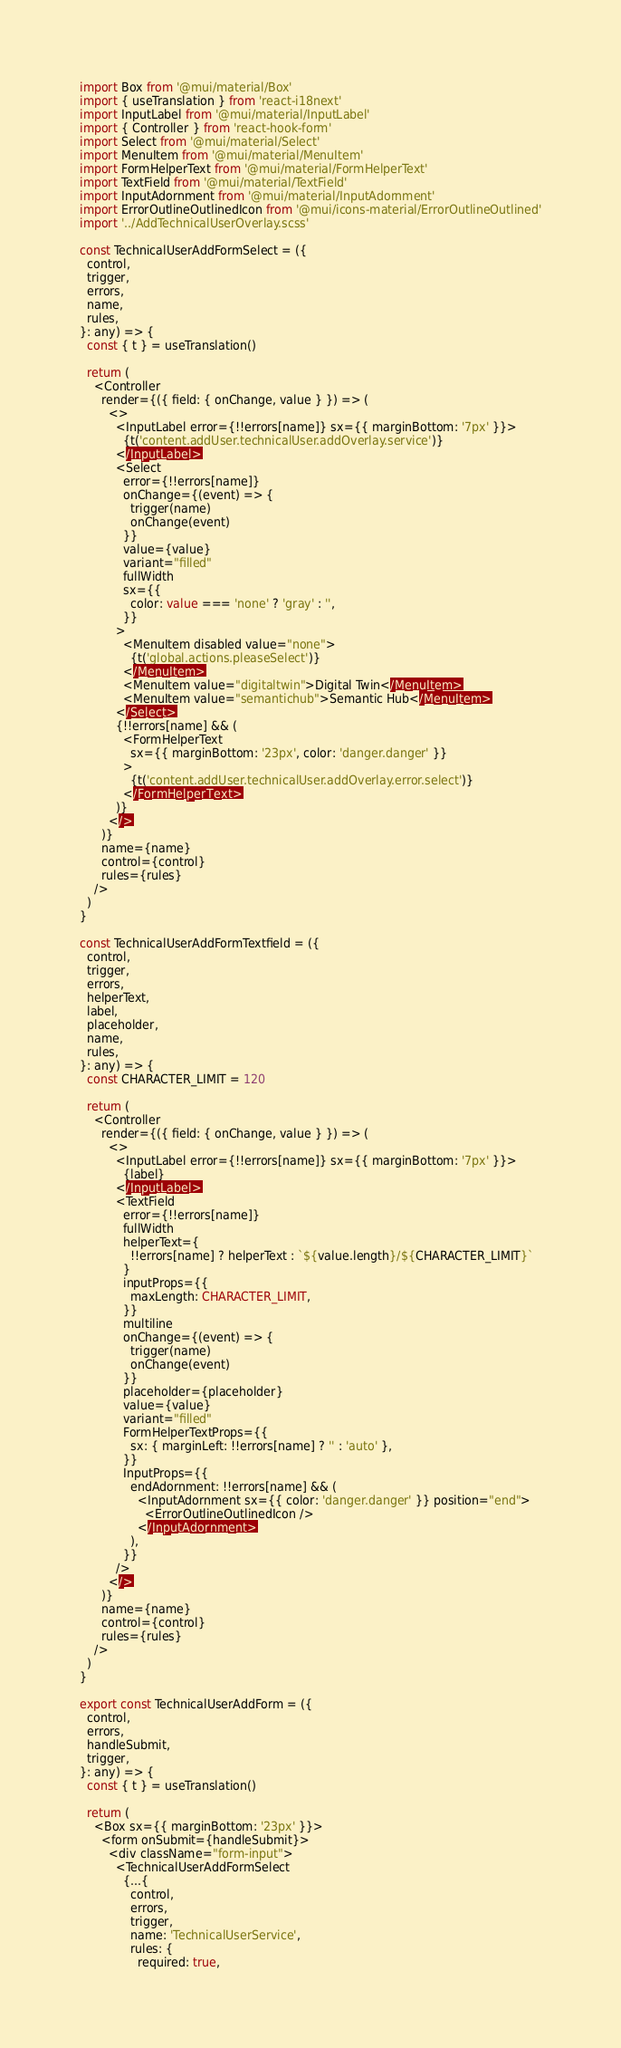<code> <loc_0><loc_0><loc_500><loc_500><_TypeScript_>import Box from '@mui/material/Box'
import { useTranslation } from 'react-i18next'
import InputLabel from '@mui/material/InputLabel'
import { Controller } from 'react-hook-form'
import Select from '@mui/material/Select'
import MenuItem from '@mui/material/MenuItem'
import FormHelperText from '@mui/material/FormHelperText'
import TextField from '@mui/material/TextField'
import InputAdornment from '@mui/material/InputAdornment'
import ErrorOutlineOutlinedIcon from '@mui/icons-material/ErrorOutlineOutlined'
import '../AddTechnicalUserOverlay.scss'

const TechnicalUserAddFormSelect = ({
  control,
  trigger,
  errors,
  name,
  rules,
}: any) => {
  const { t } = useTranslation()

  return (
    <Controller
      render={({ field: { onChange, value } }) => (
        <>
          <InputLabel error={!!errors[name]} sx={{ marginBottom: '7px' }}>
            {t('content.addUser.technicalUser.addOverlay.service')}
          </InputLabel>
          <Select
            error={!!errors[name]}
            onChange={(event) => {
              trigger(name)
              onChange(event)
            }}
            value={value}
            variant="filled"
            fullWidth
            sx={{
              color: value === 'none' ? 'gray' : '',
            }}
          >
            <MenuItem disabled value="none">
              {t('global.actions.pleaseSelect')}
            </MenuItem>
            <MenuItem value="digitaltwin">Digital Twin</MenuItem>
            <MenuItem value="semantichub">Semantic Hub</MenuItem>
          </Select>
          {!!errors[name] && (
            <FormHelperText
              sx={{ marginBottom: '23px', color: 'danger.danger' }}
            >
              {t('content.addUser.technicalUser.addOverlay.error.select')}
            </FormHelperText>
          )}
        </>
      )}
      name={name}
      control={control}
      rules={rules}
    />
  )
}

const TechnicalUserAddFormTextfield = ({
  control,
  trigger,
  errors,
  helperText,
  label,
  placeholder,
  name,
  rules,
}: any) => {
  const CHARACTER_LIMIT = 120

  return (
    <Controller
      render={({ field: { onChange, value } }) => (
        <>
          <InputLabel error={!!errors[name]} sx={{ marginBottom: '7px' }}>
            {label}
          </InputLabel>
          <TextField
            error={!!errors[name]}
            fullWidth
            helperText={
              !!errors[name] ? helperText : `${value.length}/${CHARACTER_LIMIT}`
            }
            inputProps={{
              maxLength: CHARACTER_LIMIT,
            }}
            multiline
            onChange={(event) => {
              trigger(name)
              onChange(event)
            }}
            placeholder={placeholder}
            value={value}
            variant="filled"
            FormHelperTextProps={{
              sx: { marginLeft: !!errors[name] ? '' : 'auto' },
            }}
            InputProps={{
              endAdornment: !!errors[name] && (
                <InputAdornment sx={{ color: 'danger.danger' }} position="end">
                  <ErrorOutlineOutlinedIcon />
                </InputAdornment>
              ),
            }}
          />
        </>
      )}
      name={name}
      control={control}
      rules={rules}
    />
  )
}

export const TechnicalUserAddForm = ({
  control,
  errors,
  handleSubmit,
  trigger,
}: any) => {
  const { t } = useTranslation()

  return (
    <Box sx={{ marginBottom: '23px' }}>
      <form onSubmit={handleSubmit}>
        <div className="form-input">
          <TechnicalUserAddFormSelect
            {...{
              control,
              errors,
              trigger,
              name: 'TechnicalUserService',
              rules: {
                required: true,</code> 